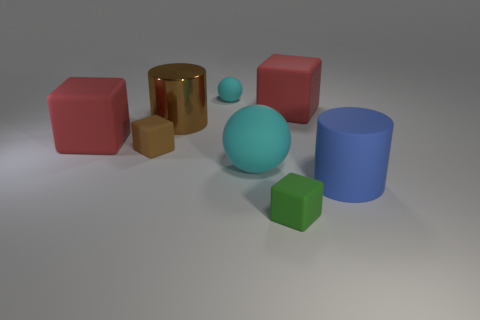There is another cyan thing that is the same size as the metal object; what is its shape?
Your response must be concise. Sphere. What is the blue thing made of?
Offer a very short reply. Rubber. There is a red thing that is behind the big red object that is left of the big red thing that is right of the small cyan matte object; how big is it?
Keep it short and to the point. Large. There is a thing that is the same color as the large metallic cylinder; what is it made of?
Give a very brief answer. Rubber. How many shiny things are either big brown cylinders or small yellow things?
Ensure brevity in your answer.  1. What is the size of the green matte object?
Give a very brief answer. Small. How many objects are tiny red metallic objects or large red matte blocks on the right side of the small green object?
Offer a very short reply. 1. What number of other things are the same color as the large shiny cylinder?
Keep it short and to the point. 1. There is a blue object; does it have the same size as the cyan thing behind the brown matte cube?
Make the answer very short. No. There is a cylinder that is left of the green block; is it the same size as the large matte cylinder?
Ensure brevity in your answer.  Yes. 